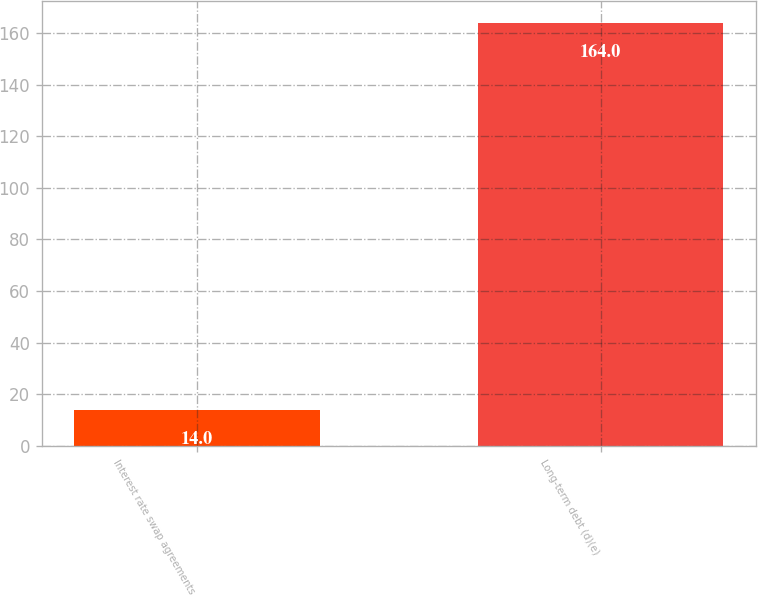Convert chart to OTSL. <chart><loc_0><loc_0><loc_500><loc_500><bar_chart><fcel>Interest rate swap agreements<fcel>Long-term debt (d)(e)<nl><fcel>14<fcel>164<nl></chart> 